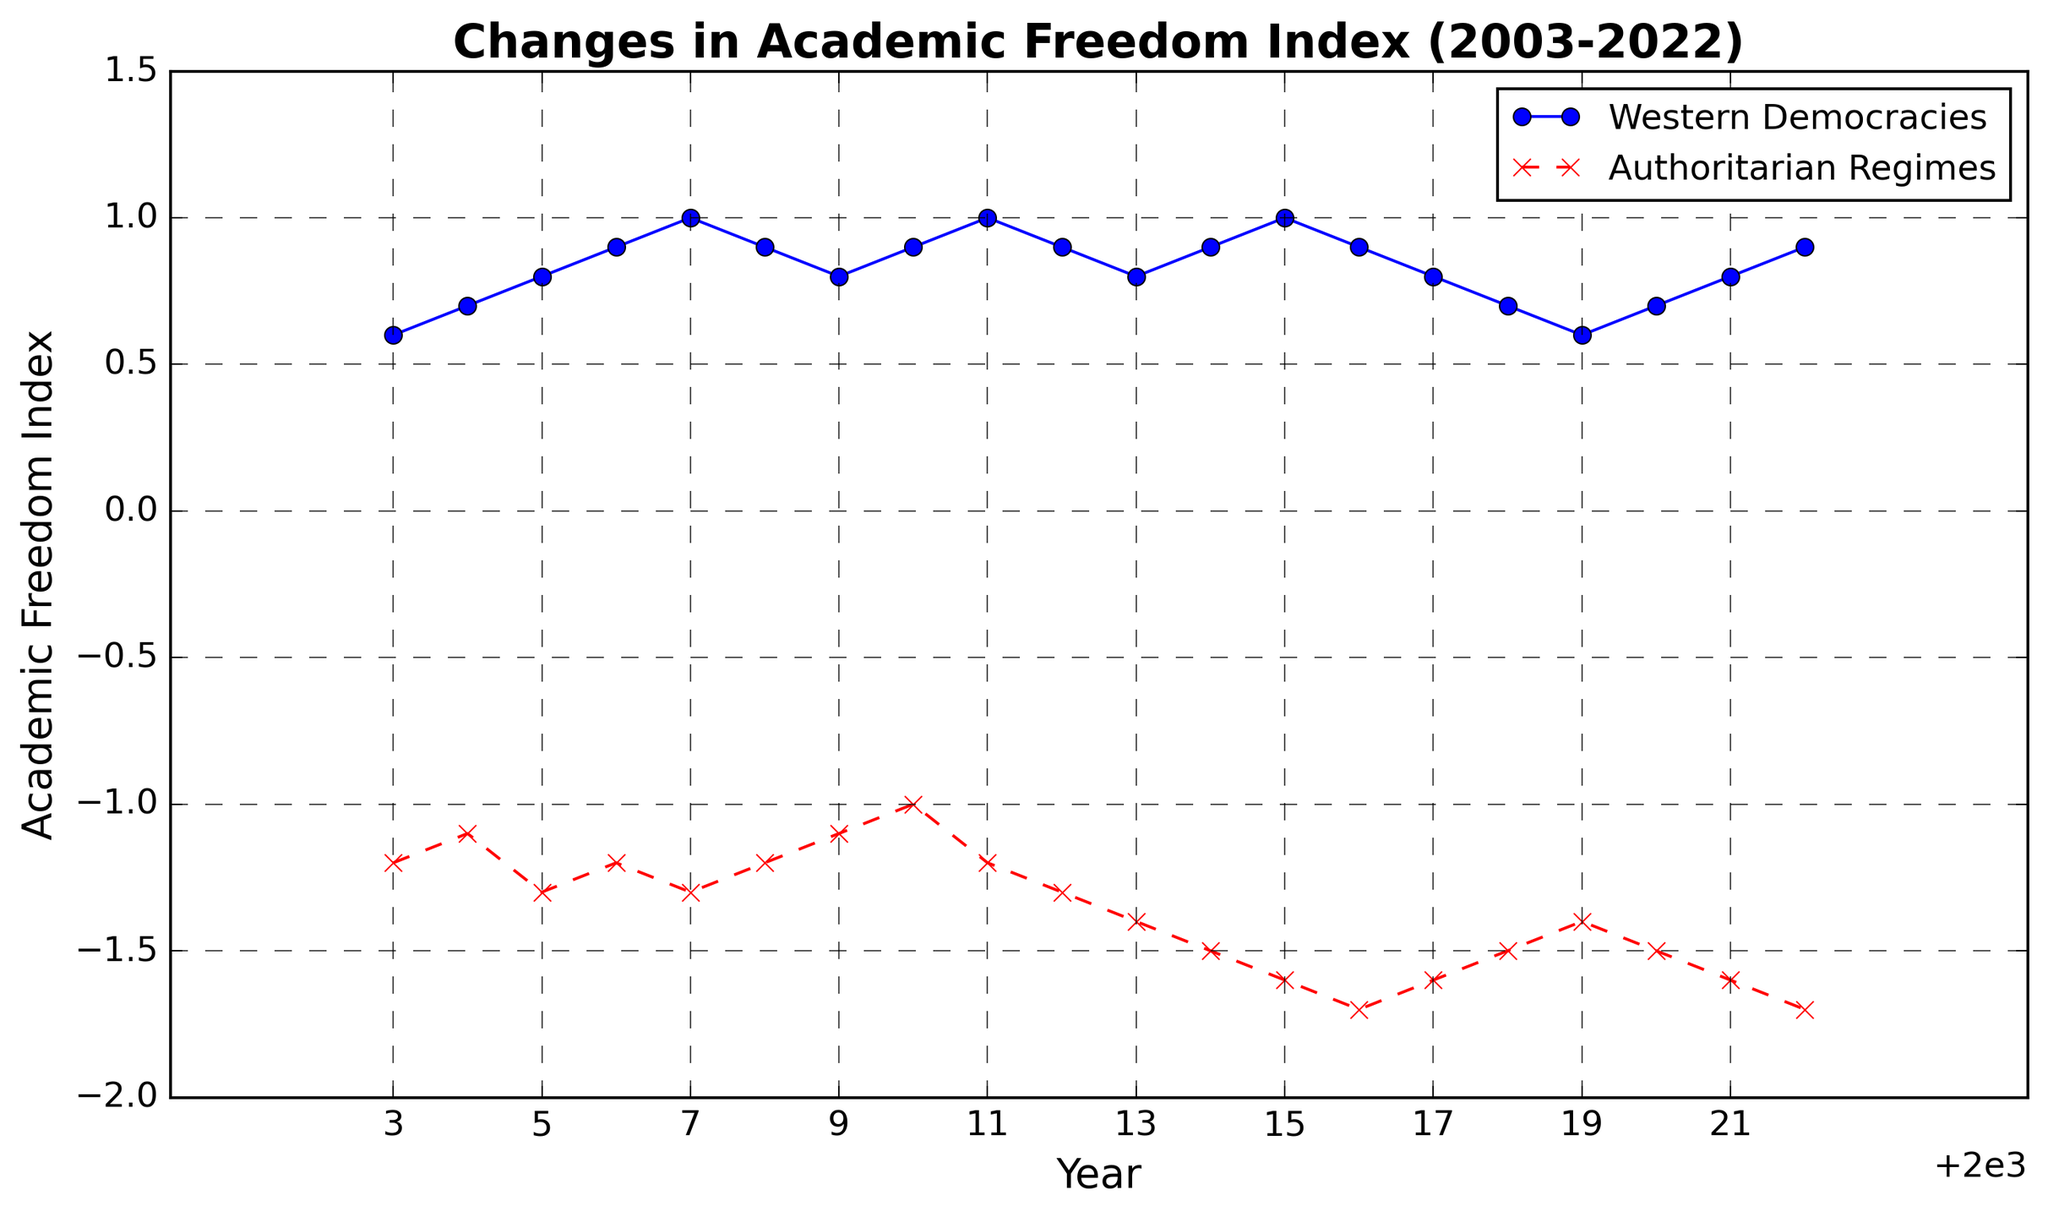When did Western Democracies reach their highest Academic Freedom Index value, and what was it? To find the highest value for Western Democracies, look for the peak point on the blue line, which occurs in 2007 and again in 2011 and 2015, with a value of 1.0
Answer: 2007, 2011, 2015; 1.0 What was the trend in the Academic Freedom Index for Authoritarian Regimes from 2003 to 2022? The red line represents Authoritarian Regimes and shows mostly a downward trend, indicating a decline in the Academic Freedom Index over the years
Answer: Downward Which regime type had a more stable Academic Freedom Index over the 20 years? Observing the blue and red lines, the Western Democracies seem more stable with smaller fluctuations compared to the Authoritarian Regimes, which show more significant variations
Answer: Western Democracies In which year did both Western Democracies and Authoritarian Regimes have the same absolute value of Academic Freedom Index, and what were these values? Look for the year when the absolute difference between the indices is the smallest. This occurs in 2010 with Western Democracies at 0.9 and Authoritarian Regimes at -1.0
Answer: 2010; 0.9, -1.0 What is the overall average Academic Freedom Index of Western Democracies over 20 years? Calculate the sum of the Academic Freedom Index values for Western Democracies (0.6+0.7+...+0.9), then divide by 20
Answer: 0.83 During which year did Authoritarian Regimes see their lowest Academic Freedom Index, and what was the value? Find the lowest point on the red line. The lowest value is -1.7 in 2016 and 2022
Answer: 2016, 2022; -1.7 Compare the trend of both regimes' Academic Freedom Index from 2010 to 2015. From 2010 to 2015, the Western Democracies line (blue) mostly trends upwards, while the Authoritarian Regimes line (red) trends downwards
Answer: Western Democracies upwards, Authoritarian Regimes downwards What was the difference in the Academic Freedom Index between the two regimes in 2007? The value for Western Democracies in 2007 is 1.0, and for Authoritarian Regimes, it is -1.3. The difference is 1.0 - (-1.3) = 2.3
Answer: 2.3 Does there appear to be any cyclical pattern in the Academic Freedom Index for either regime? For Western Democracies, there seems to be a slight cyclical pattern with minor fluctuations around the index of 0.9. For Authoritarian Regimes, the pattern is mostly a consistent decline
Answer: Slight cycle for Western Democracies, consistent decline for Authoritarian Regimes Did both regimes' Academic Freedom Indexes ever increase in the same year? Both the blue and red lines must rise during the same years. In 2020 and 2021, both regimes see an increase in their indices
Answer: 2020, 2021 